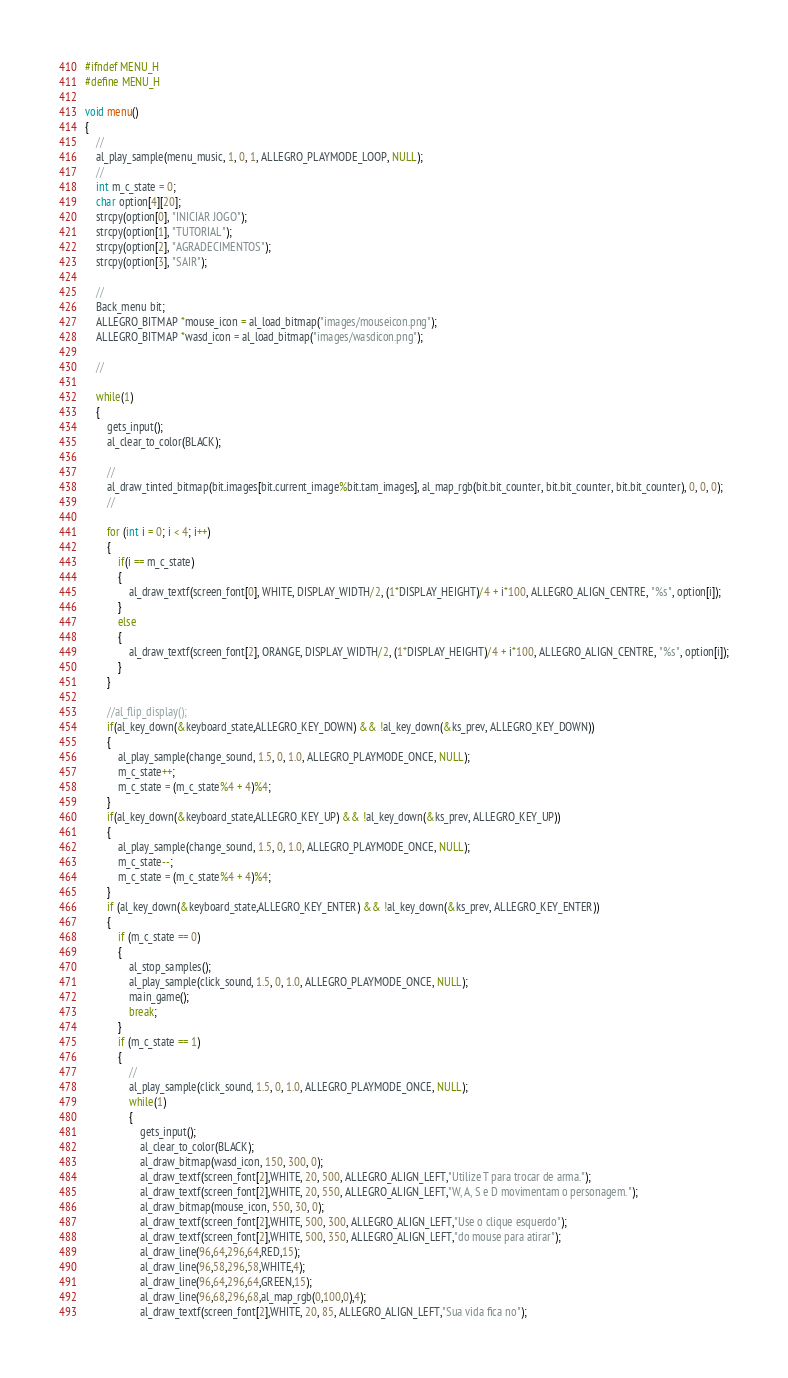Convert code to text. <code><loc_0><loc_0><loc_500><loc_500><_C_>#ifndef MENU_H
#define MENU_H

void menu()
{
	//
	al_play_sample(menu_music, 1, 0, 1, ALLEGRO_PLAYMODE_LOOP, NULL);
	//
	int m_c_state = 0;
	char option[4][20];
	strcpy(option[0], "INICIAR JOGO");
	strcpy(option[1], "TUTORIAL");
	strcpy(option[2], "AGRADECIMENTOS");
	strcpy(option[3], "SAIR");

	//
	Back_menu bit;
	ALLEGRO_BITMAP *mouse_icon = al_load_bitmap("images/mouseicon.png");
	ALLEGRO_BITMAP *wasd_icon = al_load_bitmap("images/wasdicon.png");

	//
	
	while(1)
	{
		gets_input();
		al_clear_to_color(BLACK);

		//
		al_draw_tinted_bitmap(bit.images[bit.current_image%bit.tam_images], al_map_rgb(bit.bit_counter, bit.bit_counter, bit.bit_counter), 0, 0, 0);
		//

		for (int i = 0; i < 4; i++) 
		{
			if(i == m_c_state)
			{
				al_draw_textf(screen_font[0], WHITE, DISPLAY_WIDTH/2, (1*DISPLAY_HEIGHT)/4 + i*100, ALLEGRO_ALIGN_CENTRE, "%s", option[i]);
			}
			else
			{
				al_draw_textf(screen_font[2], ORANGE, DISPLAY_WIDTH/2, (1*DISPLAY_HEIGHT)/4 + i*100, ALLEGRO_ALIGN_CENTRE, "%s", option[i]);
			}
		}

		//al_flip_display();
		if(al_key_down(&keyboard_state,ALLEGRO_KEY_DOWN) && !al_key_down(&ks_prev, ALLEGRO_KEY_DOWN))
		{
			al_play_sample(change_sound, 1.5, 0, 1.0, ALLEGRO_PLAYMODE_ONCE, NULL);
			m_c_state++;
			m_c_state = (m_c_state%4 + 4)%4;
		}
		if(al_key_down(&keyboard_state,ALLEGRO_KEY_UP) && !al_key_down(&ks_prev, ALLEGRO_KEY_UP))
		{
			al_play_sample(change_sound, 1.5, 0, 1.0, ALLEGRO_PLAYMODE_ONCE, NULL);
			m_c_state--;
			m_c_state = (m_c_state%4 + 4)%4;
		}
		if (al_key_down(&keyboard_state,ALLEGRO_KEY_ENTER) && !al_key_down(&ks_prev, ALLEGRO_KEY_ENTER))
		{
			if (m_c_state == 0)
			{
				al_stop_samples();
				al_play_sample(click_sound, 1.5, 0, 1.0, ALLEGRO_PLAYMODE_ONCE, NULL);
				main_game();				
				break;
			}
			if (m_c_state == 1)
			{
				//
				al_play_sample(click_sound, 1.5, 0, 1.0, ALLEGRO_PLAYMODE_ONCE, NULL);
				while(1)
				{
					gets_input();
					al_clear_to_color(BLACK);
					al_draw_bitmap(wasd_icon, 150, 300, 0);
					al_draw_textf(screen_font[2],WHITE, 20, 500, ALLEGRO_ALIGN_LEFT,"Utilize T para trocar de arma.");
					al_draw_textf(screen_font[2],WHITE, 20, 550, ALLEGRO_ALIGN_LEFT,"W, A, S e D movimentam o personagem.");
					al_draw_bitmap(mouse_icon, 550, 30, 0);
					al_draw_textf(screen_font[2],WHITE, 500, 300, ALLEGRO_ALIGN_LEFT,"Use o clique esquerdo");
					al_draw_textf(screen_font[2],WHITE, 500, 350, ALLEGRO_ALIGN_LEFT,"do mouse para atirar");
					al_draw_line(96,64,296,64,RED,15);
					al_draw_line(96,58,296,58,WHITE,4);
					al_draw_line(96,64,296,64,GREEN,15);
					al_draw_line(96,68,296,68,al_map_rgb(0,100,0),4);
					al_draw_textf(screen_font[2],WHITE, 20, 85, ALLEGRO_ALIGN_LEFT,"Sua vida fica no");</code> 